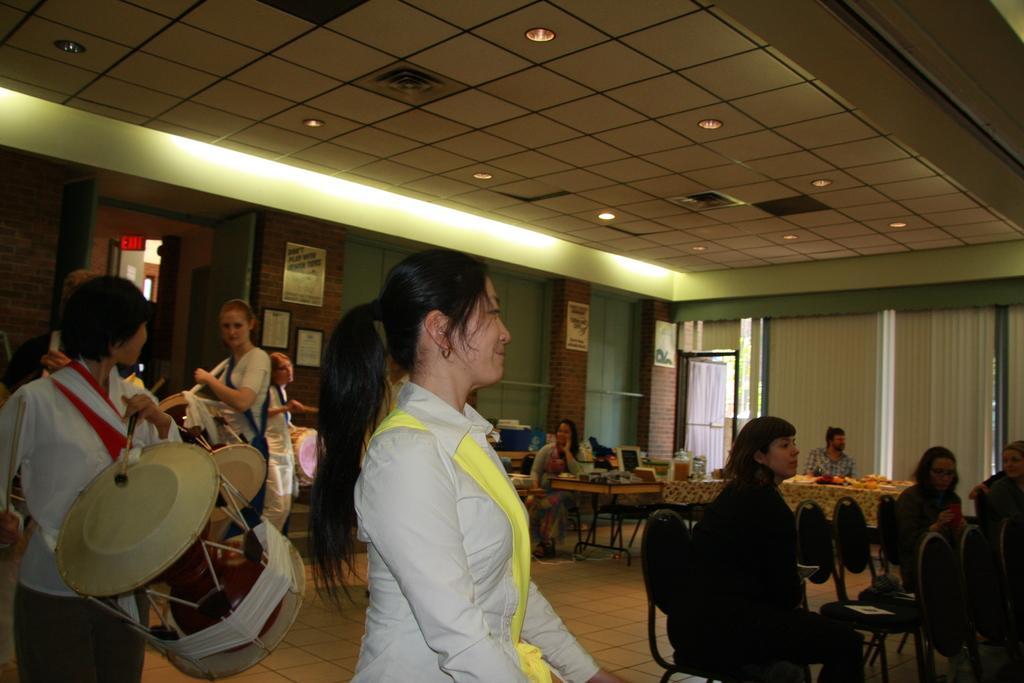How would you summarize this image in a sentence or two? This image is taken inside a room. In the middle of the image a woman is standing. In the left side of the image a woman is standing and wearing a drum on her neck. In the right side of the image there are few chairs and few people are sitting on them. At the background there is a wall, windows with curtains and few frames with text on it. At the top of the image there is a ceiling with lights. 